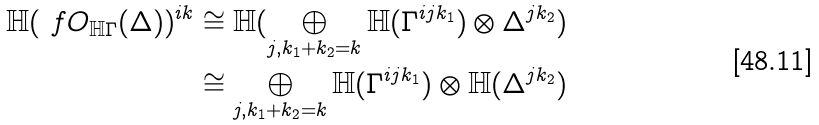Convert formula to latex. <formula><loc_0><loc_0><loc_500><loc_500>\mathbb { H } ( \ f O _ { \mathbb { H } \Gamma } ( \Delta ) ) ^ { i k } & \cong \mathbb { H } ( \bigoplus _ { j , k _ { 1 } + k _ { 2 } = k } \mathbb { H } ( \Gamma ^ { i j k _ { 1 } } ) \otimes \Delta ^ { j k _ { 2 } } ) \\ & \cong \bigoplus _ { j , k _ { 1 } + k _ { 2 } = k } \mathbb { H } ( \Gamma ^ { i j k _ { 1 } } ) \otimes \mathbb { H } ( \Delta ^ { j k _ { 2 } } )</formula> 